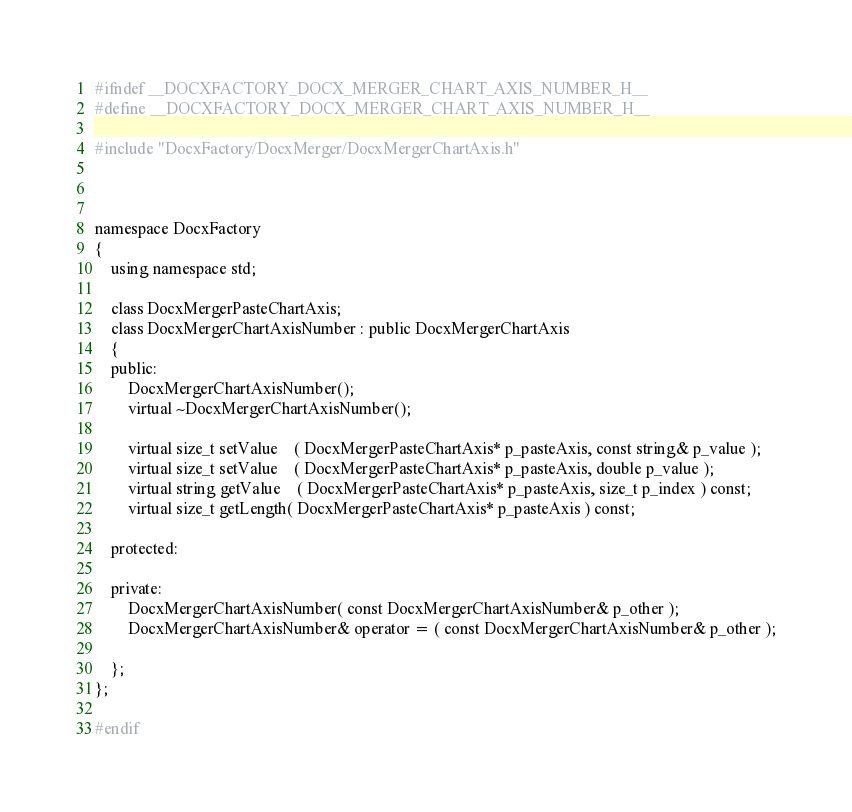<code> <loc_0><loc_0><loc_500><loc_500><_C_>
#ifndef __DOCXFACTORY_DOCX_MERGER_CHART_AXIS_NUMBER_H__
#define __DOCXFACTORY_DOCX_MERGER_CHART_AXIS_NUMBER_H__

#include "DocxFactory/DocxMerger/DocxMergerChartAxis.h"



namespace DocxFactory
{
	using namespace std;

	class DocxMergerPasteChartAxis;
	class DocxMergerChartAxisNumber : public DocxMergerChartAxis
	{
	public:
		DocxMergerChartAxisNumber();
		virtual ~DocxMergerChartAxisNumber();

		virtual size_t setValue	( DocxMergerPasteChartAxis* p_pasteAxis, const string& p_value );
		virtual size_t setValue	( DocxMergerPasteChartAxis* p_pasteAxis, double p_value );
		virtual string getValue	( DocxMergerPasteChartAxis* p_pasteAxis, size_t p_index ) const;
		virtual size_t getLength( DocxMergerPasteChartAxis* p_pasteAxis ) const;

	protected:

	private:
		DocxMergerChartAxisNumber( const DocxMergerChartAxisNumber& p_other );
		DocxMergerChartAxisNumber& operator = ( const DocxMergerChartAxisNumber& p_other );

	};
};

#endif
</code> 